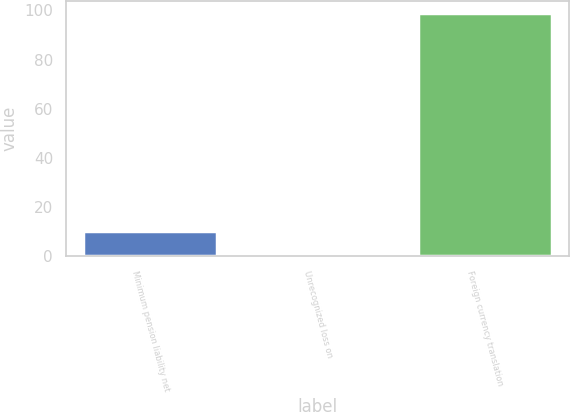Convert chart to OTSL. <chart><loc_0><loc_0><loc_500><loc_500><bar_chart><fcel>Minimum pension liability net<fcel>Unrecognized loss on<fcel>Foreign currency translation<nl><fcel>10.53<fcel>0.7<fcel>99<nl></chart> 